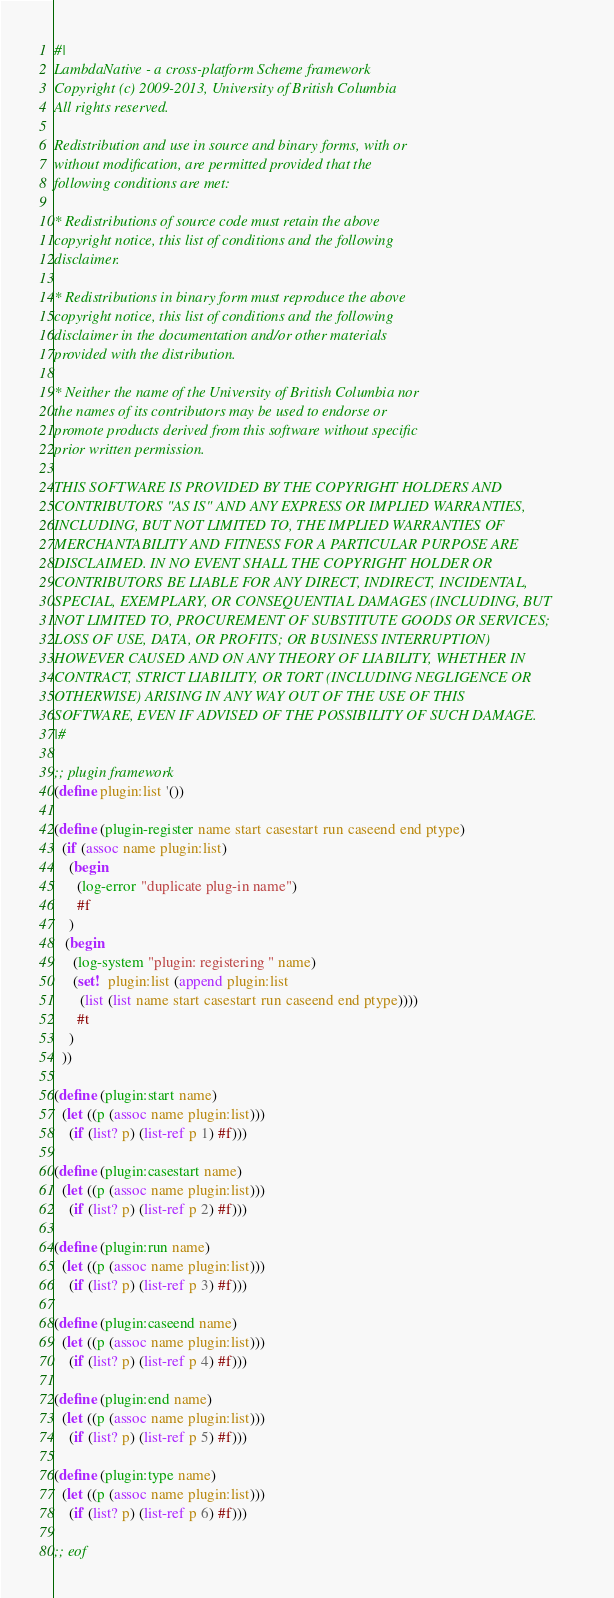<code> <loc_0><loc_0><loc_500><loc_500><_Scheme_>#|
LambdaNative - a cross-platform Scheme framework
Copyright (c) 2009-2013, University of British Columbia
All rights reserved.

Redistribution and use in source and binary forms, with or
without modification, are permitted provided that the
following conditions are met:

* Redistributions of source code must retain the above
copyright notice, this list of conditions and the following
disclaimer.

* Redistributions in binary form must reproduce the above
copyright notice, this list of conditions and the following
disclaimer in the documentation and/or other materials
provided with the distribution.

* Neither the name of the University of British Columbia nor
the names of its contributors may be used to endorse or
promote products derived from this software without specific
prior written permission.

THIS SOFTWARE IS PROVIDED BY THE COPYRIGHT HOLDERS AND
CONTRIBUTORS "AS IS" AND ANY EXPRESS OR IMPLIED WARRANTIES,
INCLUDING, BUT NOT LIMITED TO, THE IMPLIED WARRANTIES OF
MERCHANTABILITY AND FITNESS FOR A PARTICULAR PURPOSE ARE
DISCLAIMED. IN NO EVENT SHALL THE COPYRIGHT HOLDER OR
CONTRIBUTORS BE LIABLE FOR ANY DIRECT, INDIRECT, INCIDENTAL,
SPECIAL, EXEMPLARY, OR CONSEQUENTIAL DAMAGES (INCLUDING, BUT
NOT LIMITED TO, PROCUREMENT OF SUBSTITUTE GOODS OR SERVICES;
LOSS OF USE, DATA, OR PROFITS; OR BUSINESS INTERRUPTION)
HOWEVER CAUSED AND ON ANY THEORY OF LIABILITY, WHETHER IN
CONTRACT, STRICT LIABILITY, OR TORT (INCLUDING NEGLIGENCE OR
OTHERWISE) ARISING IN ANY WAY OUT OF THE USE OF THIS
SOFTWARE, EVEN IF ADVISED OF THE POSSIBILITY OF SUCH DAMAGE.
|#

;; plugin framework
(define plugin:list '())

(define (plugin-register name start casestart run caseend end ptype)
  (if (assoc name plugin:list)
    (begin
      (log-error "duplicate plug-in name")
      #f
    )
   (begin
     (log-system "plugin: registering " name)
     (set!  plugin:list (append plugin:list
       (list (list name start casestart run caseend end ptype))))
      #t
    )
  ))

(define (plugin:start name)
  (let ((p (assoc name plugin:list)))
    (if (list? p) (list-ref p 1) #f)))

(define (plugin:casestart name)
  (let ((p (assoc name plugin:list)))
    (if (list? p) (list-ref p 2) #f)))

(define (plugin:run name)
  (let ((p (assoc name plugin:list)))
    (if (list? p) (list-ref p 3) #f)))

(define (plugin:caseend name)
  (let ((p (assoc name plugin:list)))
    (if (list? p) (list-ref p 4) #f)))

(define (plugin:end name)
  (let ((p (assoc name plugin:list)))
    (if (list? p) (list-ref p 5) #f)))

(define (plugin:type name)
  (let ((p (assoc name plugin:list)))
    (if (list? p) (list-ref p 6) #f)))

;; eof</code> 